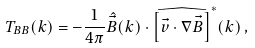Convert formula to latex. <formula><loc_0><loc_0><loc_500><loc_500>T _ { B B } ( k ) = - \frac { 1 } { 4 \pi } \hat { \vec { B } } ( k ) \cdot \widehat { \left [ \vec { v } \cdot \nabla \vec { B } \right ] } ^ { \ast } ( k ) \, ,</formula> 